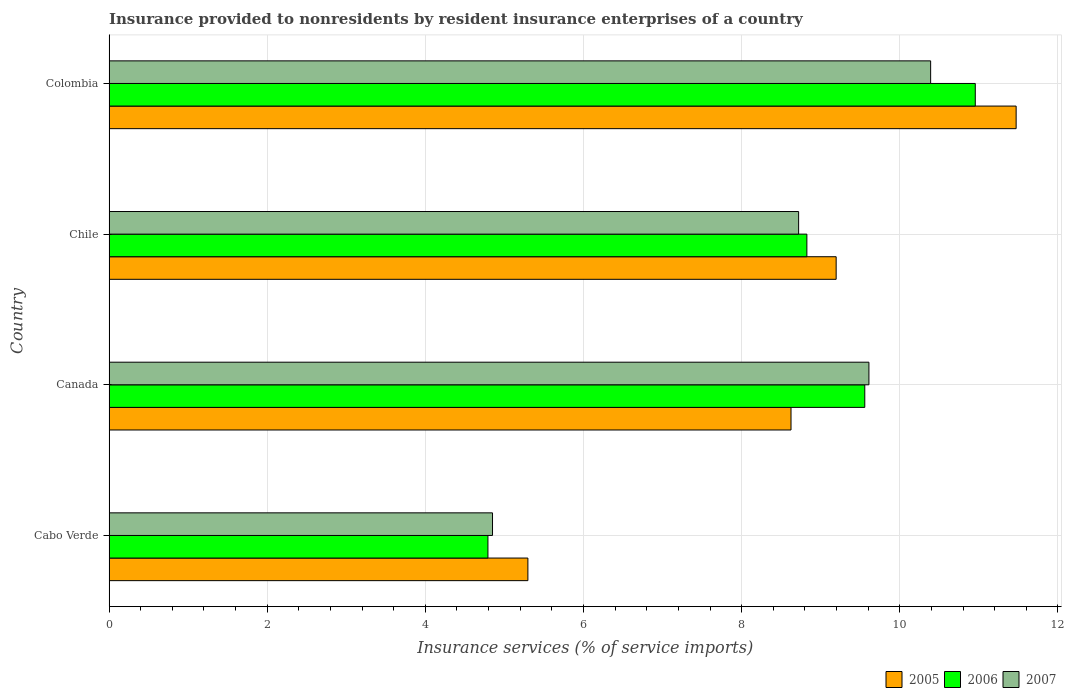How many different coloured bars are there?
Give a very brief answer. 3. How many bars are there on the 1st tick from the bottom?
Your response must be concise. 3. In how many cases, is the number of bars for a given country not equal to the number of legend labels?
Your answer should be very brief. 0. What is the insurance provided to nonresidents in 2006 in Chile?
Give a very brief answer. 8.83. Across all countries, what is the maximum insurance provided to nonresidents in 2005?
Give a very brief answer. 11.47. Across all countries, what is the minimum insurance provided to nonresidents in 2005?
Provide a short and direct response. 5.3. In which country was the insurance provided to nonresidents in 2006 maximum?
Your response must be concise. Colombia. In which country was the insurance provided to nonresidents in 2006 minimum?
Offer a very short reply. Cabo Verde. What is the total insurance provided to nonresidents in 2007 in the graph?
Your answer should be very brief. 33.57. What is the difference between the insurance provided to nonresidents in 2007 in Cabo Verde and that in Chile?
Your answer should be very brief. -3.87. What is the difference between the insurance provided to nonresidents in 2006 in Cabo Verde and the insurance provided to nonresidents in 2007 in Colombia?
Your response must be concise. -5.6. What is the average insurance provided to nonresidents in 2005 per country?
Offer a very short reply. 8.65. What is the difference between the insurance provided to nonresidents in 2006 and insurance provided to nonresidents in 2007 in Canada?
Offer a very short reply. -0.05. In how many countries, is the insurance provided to nonresidents in 2006 greater than 10.8 %?
Keep it short and to the point. 1. What is the ratio of the insurance provided to nonresidents in 2007 in Canada to that in Colombia?
Make the answer very short. 0.92. What is the difference between the highest and the second highest insurance provided to nonresidents in 2006?
Offer a very short reply. 1.4. What is the difference between the highest and the lowest insurance provided to nonresidents in 2007?
Your answer should be very brief. 5.54. Is the sum of the insurance provided to nonresidents in 2007 in Canada and Colombia greater than the maximum insurance provided to nonresidents in 2005 across all countries?
Offer a terse response. Yes. What does the 2nd bar from the top in Cabo Verde represents?
Your answer should be compact. 2006. How many bars are there?
Give a very brief answer. 12. Are all the bars in the graph horizontal?
Your response must be concise. Yes. Does the graph contain any zero values?
Provide a short and direct response. No. Does the graph contain grids?
Provide a succinct answer. Yes. Where does the legend appear in the graph?
Provide a short and direct response. Bottom right. How are the legend labels stacked?
Offer a very short reply. Horizontal. What is the title of the graph?
Your answer should be very brief. Insurance provided to nonresidents by resident insurance enterprises of a country. Does "1969" appear as one of the legend labels in the graph?
Give a very brief answer. No. What is the label or title of the X-axis?
Give a very brief answer. Insurance services (% of service imports). What is the label or title of the Y-axis?
Offer a terse response. Country. What is the Insurance services (% of service imports) of 2005 in Cabo Verde?
Provide a succinct answer. 5.3. What is the Insurance services (% of service imports) in 2006 in Cabo Verde?
Your answer should be compact. 4.79. What is the Insurance services (% of service imports) in 2007 in Cabo Verde?
Give a very brief answer. 4.85. What is the Insurance services (% of service imports) in 2005 in Canada?
Give a very brief answer. 8.62. What is the Insurance services (% of service imports) in 2006 in Canada?
Keep it short and to the point. 9.56. What is the Insurance services (% of service imports) of 2007 in Canada?
Keep it short and to the point. 9.61. What is the Insurance services (% of service imports) of 2005 in Chile?
Your answer should be compact. 9.2. What is the Insurance services (% of service imports) of 2006 in Chile?
Offer a very short reply. 8.83. What is the Insurance services (% of service imports) of 2007 in Chile?
Give a very brief answer. 8.72. What is the Insurance services (% of service imports) in 2005 in Colombia?
Your answer should be very brief. 11.47. What is the Insurance services (% of service imports) in 2006 in Colombia?
Your answer should be compact. 10.96. What is the Insurance services (% of service imports) in 2007 in Colombia?
Provide a short and direct response. 10.39. Across all countries, what is the maximum Insurance services (% of service imports) in 2005?
Offer a terse response. 11.47. Across all countries, what is the maximum Insurance services (% of service imports) of 2006?
Ensure brevity in your answer.  10.96. Across all countries, what is the maximum Insurance services (% of service imports) of 2007?
Your response must be concise. 10.39. Across all countries, what is the minimum Insurance services (% of service imports) of 2005?
Make the answer very short. 5.3. Across all countries, what is the minimum Insurance services (% of service imports) of 2006?
Provide a succinct answer. 4.79. Across all countries, what is the minimum Insurance services (% of service imports) of 2007?
Keep it short and to the point. 4.85. What is the total Insurance services (% of service imports) in 2005 in the graph?
Provide a short and direct response. 34.59. What is the total Insurance services (% of service imports) in 2006 in the graph?
Your answer should be compact. 34.13. What is the total Insurance services (% of service imports) in 2007 in the graph?
Offer a terse response. 33.57. What is the difference between the Insurance services (% of service imports) of 2005 in Cabo Verde and that in Canada?
Your response must be concise. -3.33. What is the difference between the Insurance services (% of service imports) of 2006 in Cabo Verde and that in Canada?
Your answer should be compact. -4.77. What is the difference between the Insurance services (% of service imports) of 2007 in Cabo Verde and that in Canada?
Your answer should be very brief. -4.76. What is the difference between the Insurance services (% of service imports) of 2005 in Cabo Verde and that in Chile?
Ensure brevity in your answer.  -3.9. What is the difference between the Insurance services (% of service imports) in 2006 in Cabo Verde and that in Chile?
Your answer should be compact. -4.03. What is the difference between the Insurance services (% of service imports) in 2007 in Cabo Verde and that in Chile?
Offer a very short reply. -3.87. What is the difference between the Insurance services (% of service imports) of 2005 in Cabo Verde and that in Colombia?
Give a very brief answer. -6.17. What is the difference between the Insurance services (% of service imports) in 2006 in Cabo Verde and that in Colombia?
Your response must be concise. -6.16. What is the difference between the Insurance services (% of service imports) in 2007 in Cabo Verde and that in Colombia?
Provide a succinct answer. -5.54. What is the difference between the Insurance services (% of service imports) of 2005 in Canada and that in Chile?
Your response must be concise. -0.57. What is the difference between the Insurance services (% of service imports) of 2006 in Canada and that in Chile?
Make the answer very short. 0.73. What is the difference between the Insurance services (% of service imports) in 2007 in Canada and that in Chile?
Make the answer very short. 0.89. What is the difference between the Insurance services (% of service imports) of 2005 in Canada and that in Colombia?
Offer a very short reply. -2.85. What is the difference between the Insurance services (% of service imports) of 2006 in Canada and that in Colombia?
Offer a terse response. -1.4. What is the difference between the Insurance services (% of service imports) in 2007 in Canada and that in Colombia?
Ensure brevity in your answer.  -0.78. What is the difference between the Insurance services (% of service imports) in 2005 in Chile and that in Colombia?
Make the answer very short. -2.28. What is the difference between the Insurance services (% of service imports) of 2006 in Chile and that in Colombia?
Offer a terse response. -2.13. What is the difference between the Insurance services (% of service imports) in 2007 in Chile and that in Colombia?
Give a very brief answer. -1.67. What is the difference between the Insurance services (% of service imports) in 2005 in Cabo Verde and the Insurance services (% of service imports) in 2006 in Canada?
Ensure brevity in your answer.  -4.26. What is the difference between the Insurance services (% of service imports) in 2005 in Cabo Verde and the Insurance services (% of service imports) in 2007 in Canada?
Give a very brief answer. -4.31. What is the difference between the Insurance services (% of service imports) in 2006 in Cabo Verde and the Insurance services (% of service imports) in 2007 in Canada?
Make the answer very short. -4.82. What is the difference between the Insurance services (% of service imports) of 2005 in Cabo Verde and the Insurance services (% of service imports) of 2006 in Chile?
Your answer should be very brief. -3.53. What is the difference between the Insurance services (% of service imports) of 2005 in Cabo Verde and the Insurance services (% of service imports) of 2007 in Chile?
Ensure brevity in your answer.  -3.42. What is the difference between the Insurance services (% of service imports) in 2006 in Cabo Verde and the Insurance services (% of service imports) in 2007 in Chile?
Keep it short and to the point. -3.93. What is the difference between the Insurance services (% of service imports) in 2005 in Cabo Verde and the Insurance services (% of service imports) in 2006 in Colombia?
Ensure brevity in your answer.  -5.66. What is the difference between the Insurance services (% of service imports) of 2005 in Cabo Verde and the Insurance services (% of service imports) of 2007 in Colombia?
Provide a short and direct response. -5.09. What is the difference between the Insurance services (% of service imports) of 2006 in Cabo Verde and the Insurance services (% of service imports) of 2007 in Colombia?
Your response must be concise. -5.6. What is the difference between the Insurance services (% of service imports) of 2005 in Canada and the Insurance services (% of service imports) of 2006 in Chile?
Ensure brevity in your answer.  -0.2. What is the difference between the Insurance services (% of service imports) of 2005 in Canada and the Insurance services (% of service imports) of 2007 in Chile?
Your answer should be compact. -0.1. What is the difference between the Insurance services (% of service imports) in 2006 in Canada and the Insurance services (% of service imports) in 2007 in Chile?
Make the answer very short. 0.84. What is the difference between the Insurance services (% of service imports) in 2005 in Canada and the Insurance services (% of service imports) in 2006 in Colombia?
Provide a short and direct response. -2.33. What is the difference between the Insurance services (% of service imports) in 2005 in Canada and the Insurance services (% of service imports) in 2007 in Colombia?
Keep it short and to the point. -1.77. What is the difference between the Insurance services (% of service imports) of 2006 in Canada and the Insurance services (% of service imports) of 2007 in Colombia?
Offer a very short reply. -0.83. What is the difference between the Insurance services (% of service imports) in 2005 in Chile and the Insurance services (% of service imports) in 2006 in Colombia?
Provide a succinct answer. -1.76. What is the difference between the Insurance services (% of service imports) in 2005 in Chile and the Insurance services (% of service imports) in 2007 in Colombia?
Your response must be concise. -1.19. What is the difference between the Insurance services (% of service imports) in 2006 in Chile and the Insurance services (% of service imports) in 2007 in Colombia?
Ensure brevity in your answer.  -1.57. What is the average Insurance services (% of service imports) in 2005 per country?
Your answer should be compact. 8.65. What is the average Insurance services (% of service imports) of 2006 per country?
Your response must be concise. 8.53. What is the average Insurance services (% of service imports) of 2007 per country?
Make the answer very short. 8.39. What is the difference between the Insurance services (% of service imports) of 2005 and Insurance services (% of service imports) of 2006 in Cabo Verde?
Offer a very short reply. 0.51. What is the difference between the Insurance services (% of service imports) of 2005 and Insurance services (% of service imports) of 2007 in Cabo Verde?
Make the answer very short. 0.45. What is the difference between the Insurance services (% of service imports) of 2006 and Insurance services (% of service imports) of 2007 in Cabo Verde?
Offer a terse response. -0.06. What is the difference between the Insurance services (% of service imports) in 2005 and Insurance services (% of service imports) in 2006 in Canada?
Your response must be concise. -0.93. What is the difference between the Insurance services (% of service imports) in 2005 and Insurance services (% of service imports) in 2007 in Canada?
Provide a succinct answer. -0.99. What is the difference between the Insurance services (% of service imports) of 2006 and Insurance services (% of service imports) of 2007 in Canada?
Provide a succinct answer. -0.05. What is the difference between the Insurance services (% of service imports) in 2005 and Insurance services (% of service imports) in 2006 in Chile?
Offer a very short reply. 0.37. What is the difference between the Insurance services (% of service imports) of 2005 and Insurance services (% of service imports) of 2007 in Chile?
Offer a very short reply. 0.47. What is the difference between the Insurance services (% of service imports) of 2006 and Insurance services (% of service imports) of 2007 in Chile?
Make the answer very short. 0.1. What is the difference between the Insurance services (% of service imports) in 2005 and Insurance services (% of service imports) in 2006 in Colombia?
Your answer should be compact. 0.52. What is the difference between the Insurance services (% of service imports) in 2005 and Insurance services (% of service imports) in 2007 in Colombia?
Your answer should be very brief. 1.08. What is the difference between the Insurance services (% of service imports) in 2006 and Insurance services (% of service imports) in 2007 in Colombia?
Offer a very short reply. 0.56. What is the ratio of the Insurance services (% of service imports) in 2005 in Cabo Verde to that in Canada?
Make the answer very short. 0.61. What is the ratio of the Insurance services (% of service imports) of 2006 in Cabo Verde to that in Canada?
Provide a succinct answer. 0.5. What is the ratio of the Insurance services (% of service imports) in 2007 in Cabo Verde to that in Canada?
Ensure brevity in your answer.  0.5. What is the ratio of the Insurance services (% of service imports) of 2005 in Cabo Verde to that in Chile?
Make the answer very short. 0.58. What is the ratio of the Insurance services (% of service imports) of 2006 in Cabo Verde to that in Chile?
Offer a terse response. 0.54. What is the ratio of the Insurance services (% of service imports) in 2007 in Cabo Verde to that in Chile?
Ensure brevity in your answer.  0.56. What is the ratio of the Insurance services (% of service imports) of 2005 in Cabo Verde to that in Colombia?
Your response must be concise. 0.46. What is the ratio of the Insurance services (% of service imports) in 2006 in Cabo Verde to that in Colombia?
Your answer should be compact. 0.44. What is the ratio of the Insurance services (% of service imports) of 2007 in Cabo Verde to that in Colombia?
Your answer should be very brief. 0.47. What is the ratio of the Insurance services (% of service imports) in 2005 in Canada to that in Chile?
Your response must be concise. 0.94. What is the ratio of the Insurance services (% of service imports) of 2006 in Canada to that in Chile?
Make the answer very short. 1.08. What is the ratio of the Insurance services (% of service imports) in 2007 in Canada to that in Chile?
Ensure brevity in your answer.  1.1. What is the ratio of the Insurance services (% of service imports) in 2005 in Canada to that in Colombia?
Your answer should be compact. 0.75. What is the ratio of the Insurance services (% of service imports) in 2006 in Canada to that in Colombia?
Provide a short and direct response. 0.87. What is the ratio of the Insurance services (% of service imports) in 2007 in Canada to that in Colombia?
Your response must be concise. 0.92. What is the ratio of the Insurance services (% of service imports) of 2005 in Chile to that in Colombia?
Provide a succinct answer. 0.8. What is the ratio of the Insurance services (% of service imports) in 2006 in Chile to that in Colombia?
Keep it short and to the point. 0.81. What is the ratio of the Insurance services (% of service imports) in 2007 in Chile to that in Colombia?
Make the answer very short. 0.84. What is the difference between the highest and the second highest Insurance services (% of service imports) in 2005?
Provide a succinct answer. 2.28. What is the difference between the highest and the second highest Insurance services (% of service imports) of 2006?
Give a very brief answer. 1.4. What is the difference between the highest and the second highest Insurance services (% of service imports) of 2007?
Offer a terse response. 0.78. What is the difference between the highest and the lowest Insurance services (% of service imports) of 2005?
Give a very brief answer. 6.17. What is the difference between the highest and the lowest Insurance services (% of service imports) in 2006?
Make the answer very short. 6.16. What is the difference between the highest and the lowest Insurance services (% of service imports) in 2007?
Your answer should be compact. 5.54. 